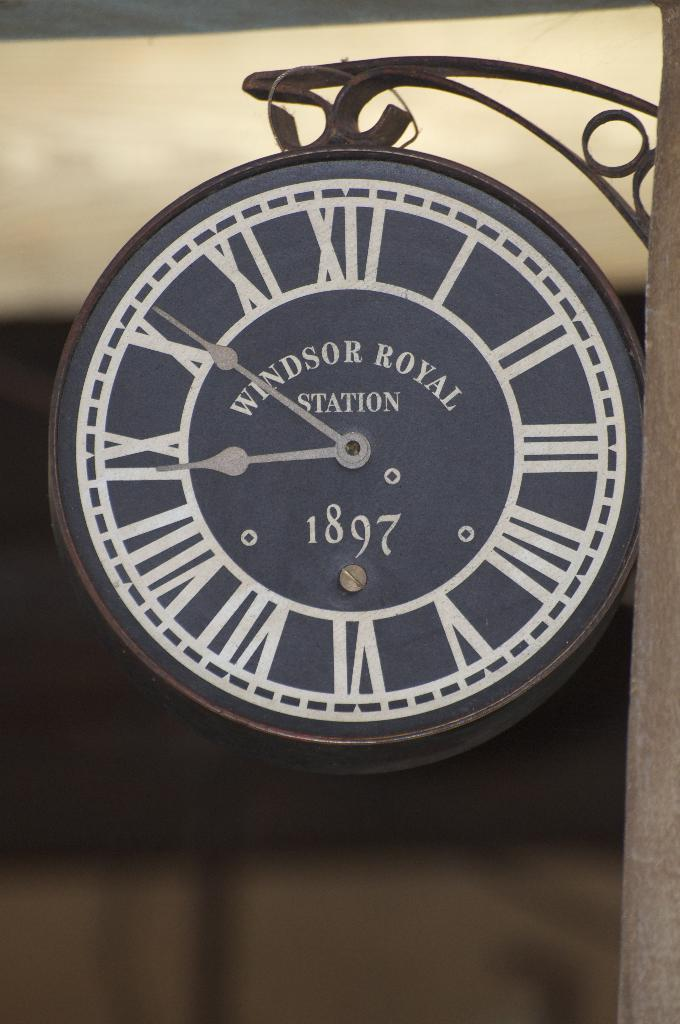Provide a one-sentence caption for the provided image. A clock that says Windsor Royal Station and 1897 on the face of it. 